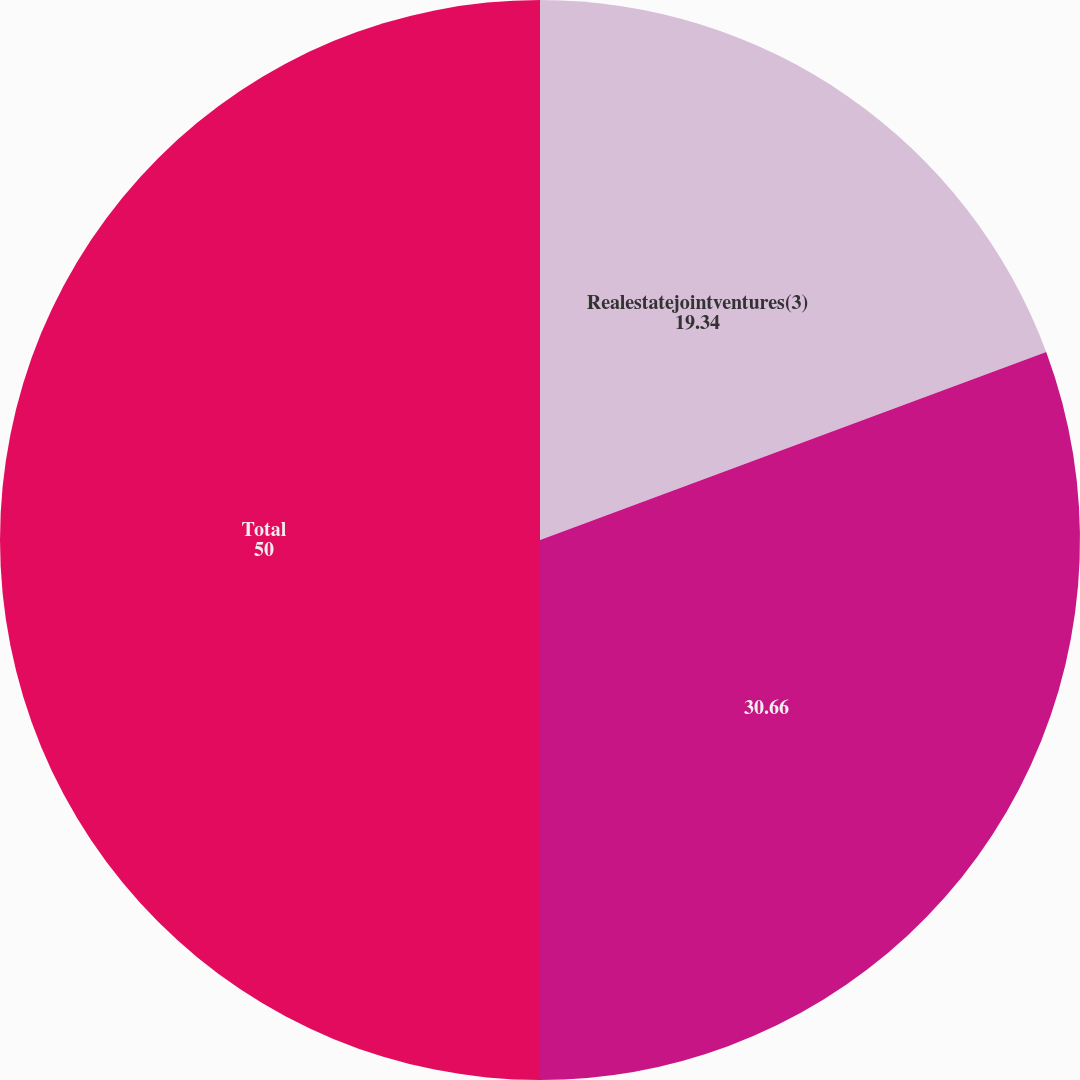Convert chart. <chart><loc_0><loc_0><loc_500><loc_500><pie_chart><fcel>Realestatejointventures(3)<fcel>Unnamed: 1<fcel>Total<nl><fcel>19.34%<fcel>30.66%<fcel>50.0%<nl></chart> 